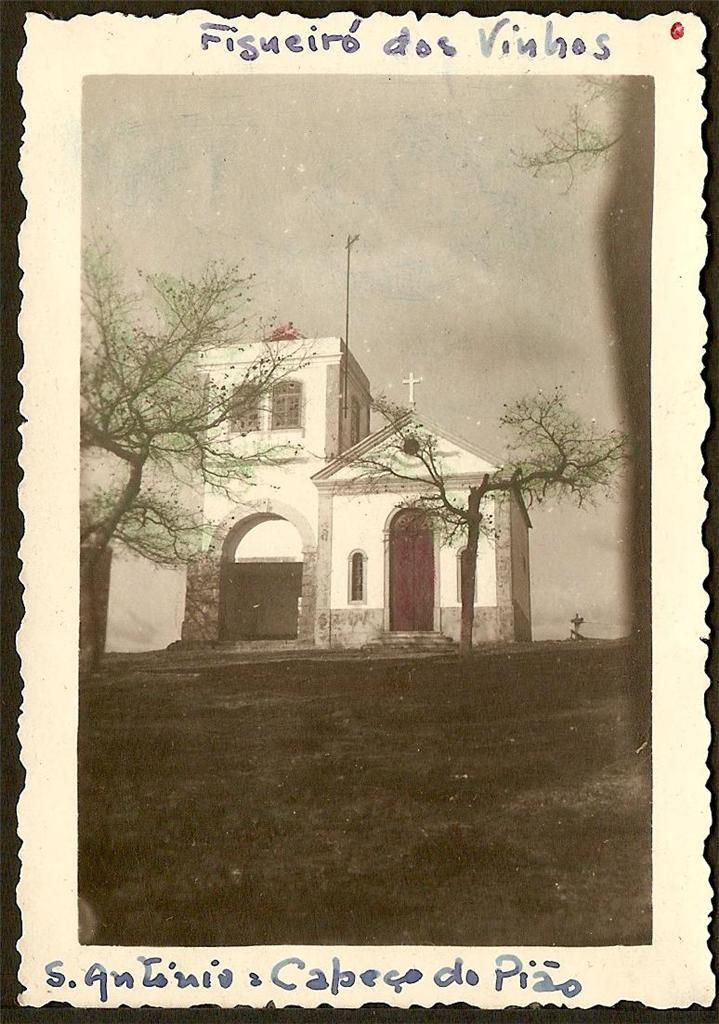<image>
Offer a succinct explanation of the picture presented. An old picture of a church called A Antonia Capego do Pizo sits in the background 